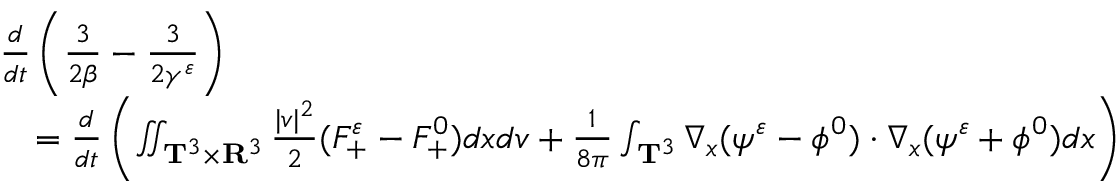Convert formula to latex. <formula><loc_0><loc_0><loc_500><loc_500>\begin{array} { r l } & { \frac { d } { d t } \left ( \frac { 3 } { 2 \beta } - \frac { 3 } { 2 \gamma ^ { \varepsilon } } \right ) } \\ & { \quad = \frac { d } { d t } \left ( \iint _ { \mathbf T ^ { 3 } \times \mathbf R ^ { 3 } } \frac { | v | ^ { 2 } } { 2 } ( F _ { + } ^ { \varepsilon } - F _ { + } ^ { 0 } ) d x d v + \frac { 1 } { 8 \pi } \int _ { \mathbf T ^ { 3 } } \nabla _ { x } ( \psi ^ { \varepsilon } - \phi ^ { 0 } ) \cdot \nabla _ { x } ( \psi ^ { \varepsilon } + \phi ^ { 0 } ) d x \right ) } \end{array}</formula> 